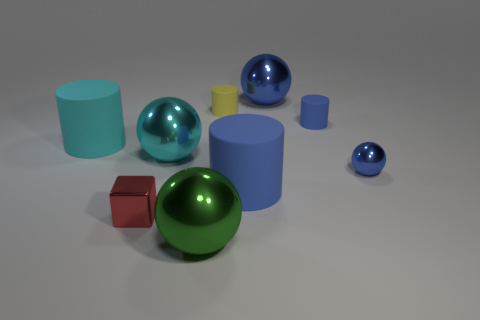Subtract 1 cylinders. How many cylinders are left? 3 Subtract all yellow cylinders. How many cylinders are left? 3 Subtract all big balls. How many balls are left? 1 Subtract all brown spheres. Subtract all brown cylinders. How many spheres are left? 4 Subtract all balls. How many objects are left? 5 Subtract all small cyan metal balls. Subtract all big cyan metal balls. How many objects are left? 8 Add 4 small yellow cylinders. How many small yellow cylinders are left? 5 Add 5 tiny yellow cylinders. How many tiny yellow cylinders exist? 6 Subtract 1 yellow cylinders. How many objects are left? 8 